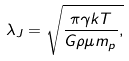Convert formula to latex. <formula><loc_0><loc_0><loc_500><loc_500>\lambda _ { J } = \sqrt { \frac { \pi \gamma k T } { G \rho \mu m _ { p } } , }</formula> 